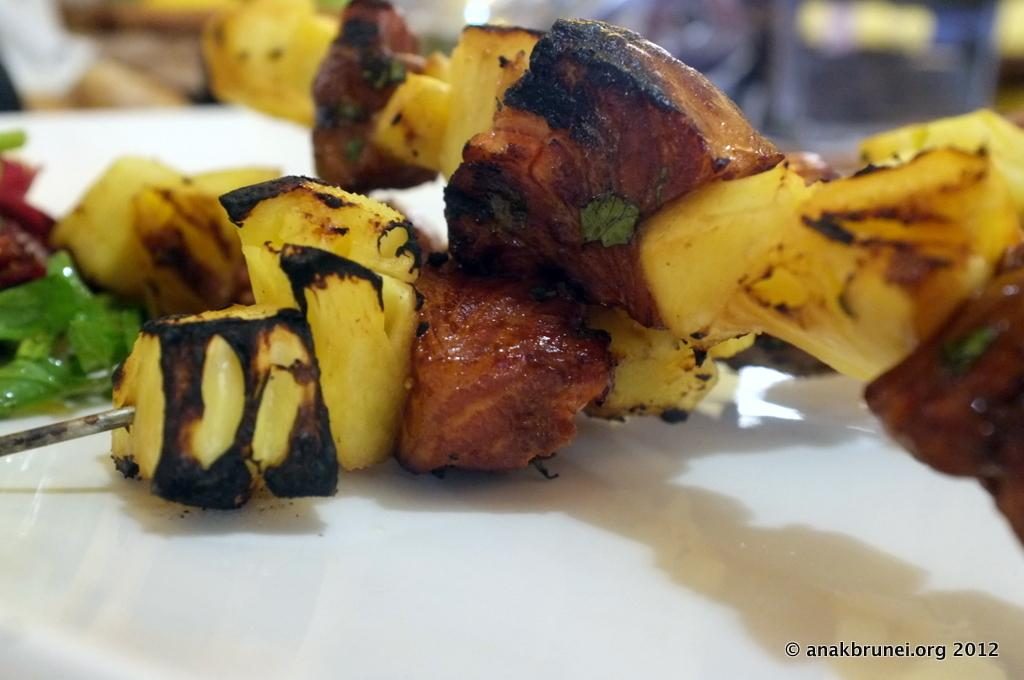What can be seen on the white surface in the image? There are food items on a white color surface in the image. Is there any text or logo visible in the image? Yes, there is a watermark at the bottom right side of the image. How would you describe the background of the image? The background of the image is blurred. What type of dress is being worn by the person on the coast in the image? There is no person or coast visible in the image; it only features food items on a white surface and a blurred background. 